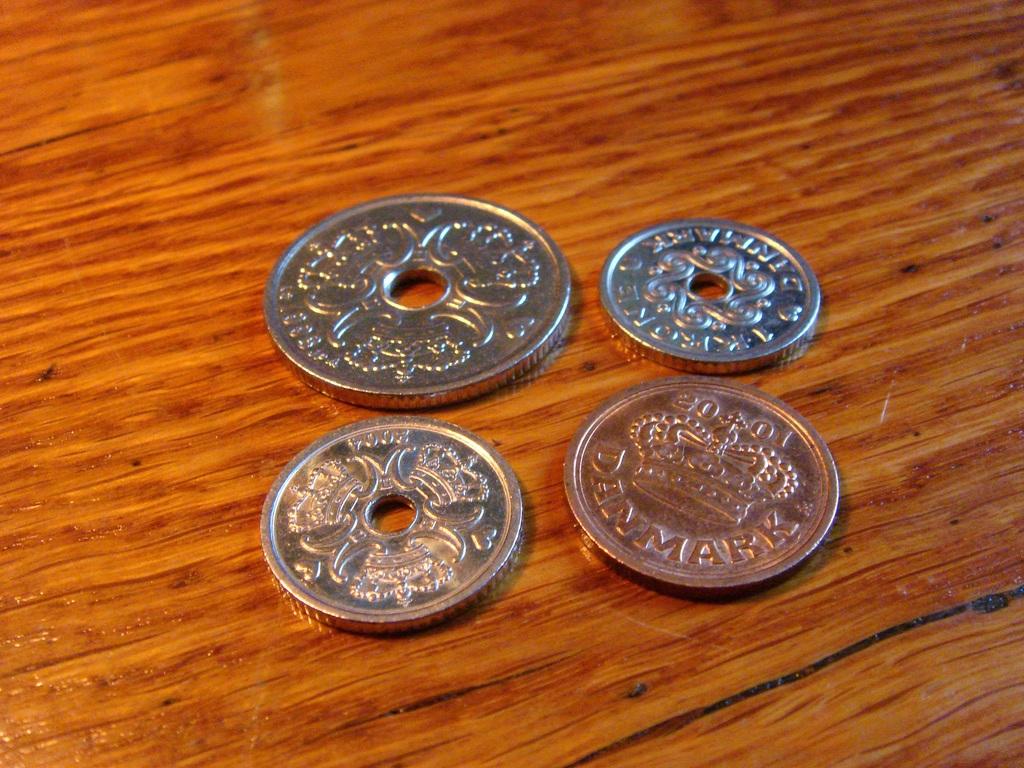Where is this currency from?
Make the answer very short. Denmark. What year is the coin?
Your answer should be very brief. 2001. 